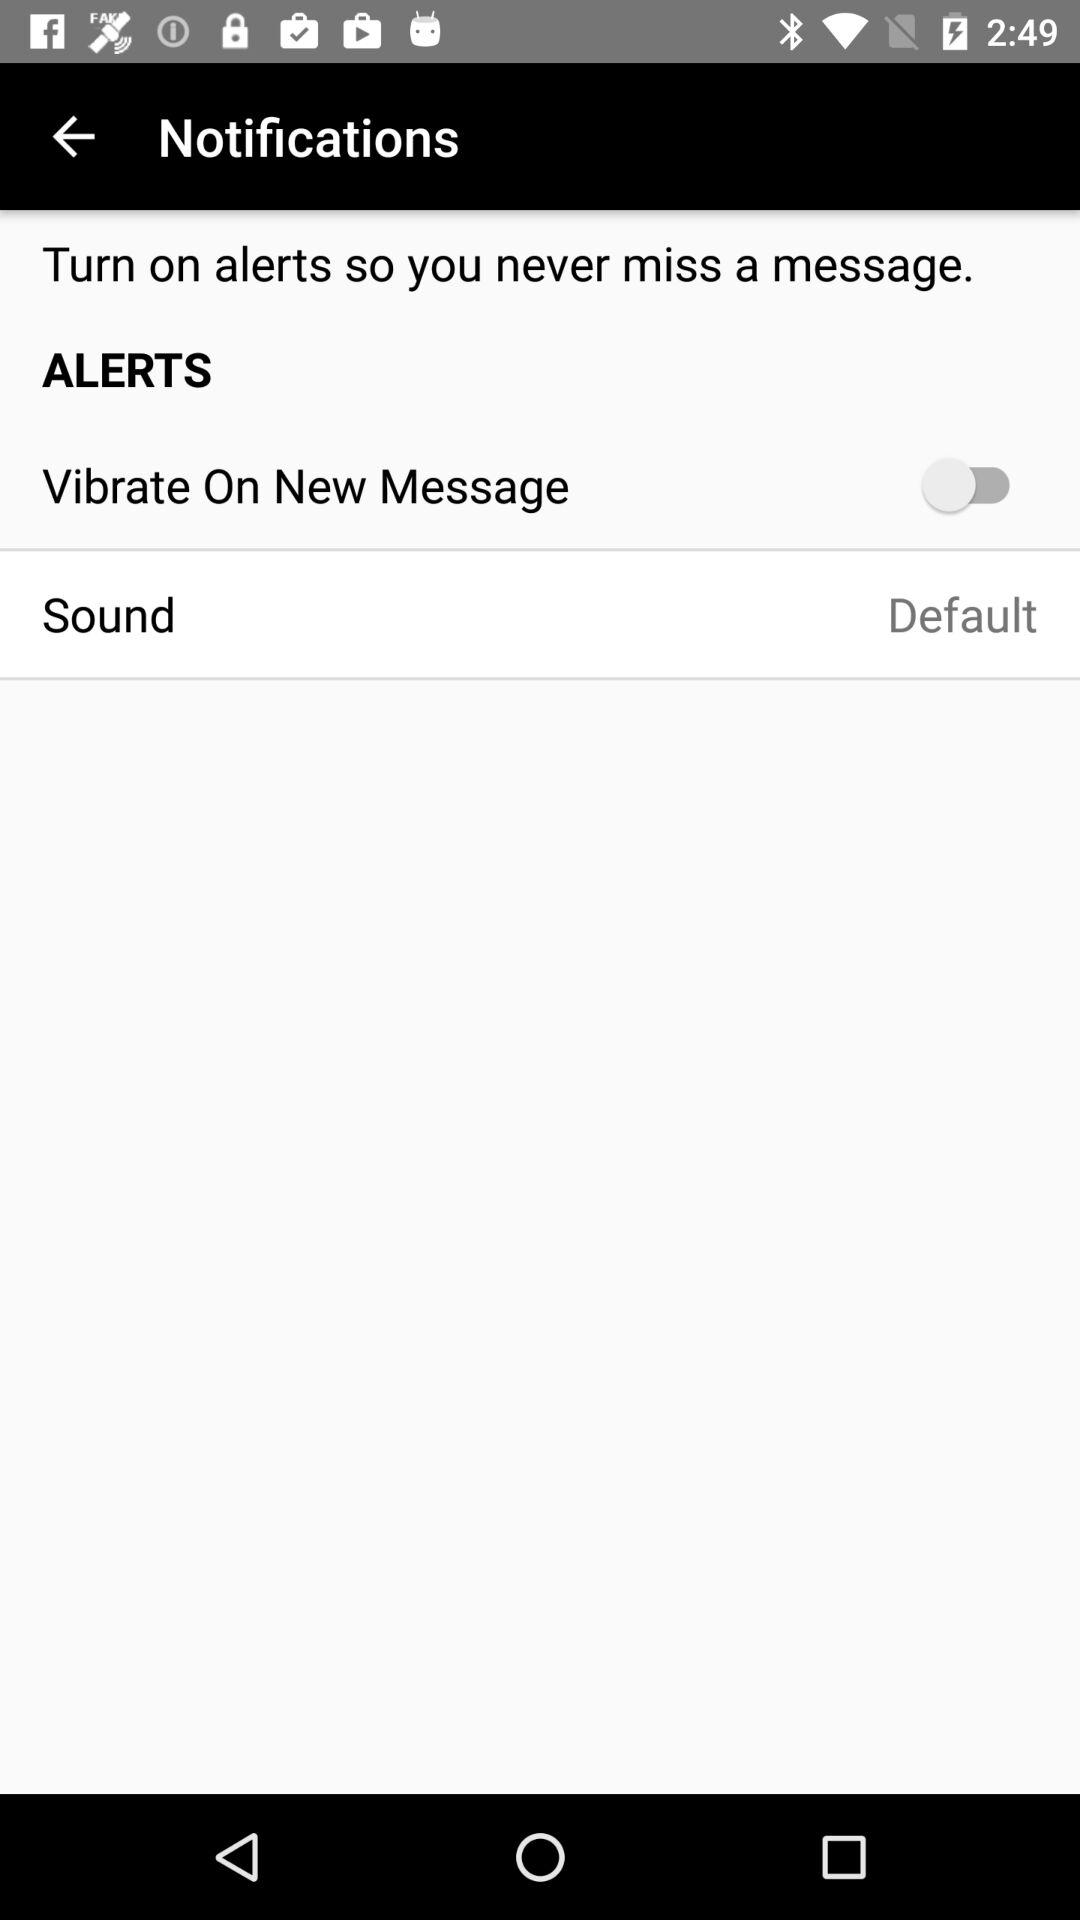What is the current setting for sound? The current setting is "Default". 